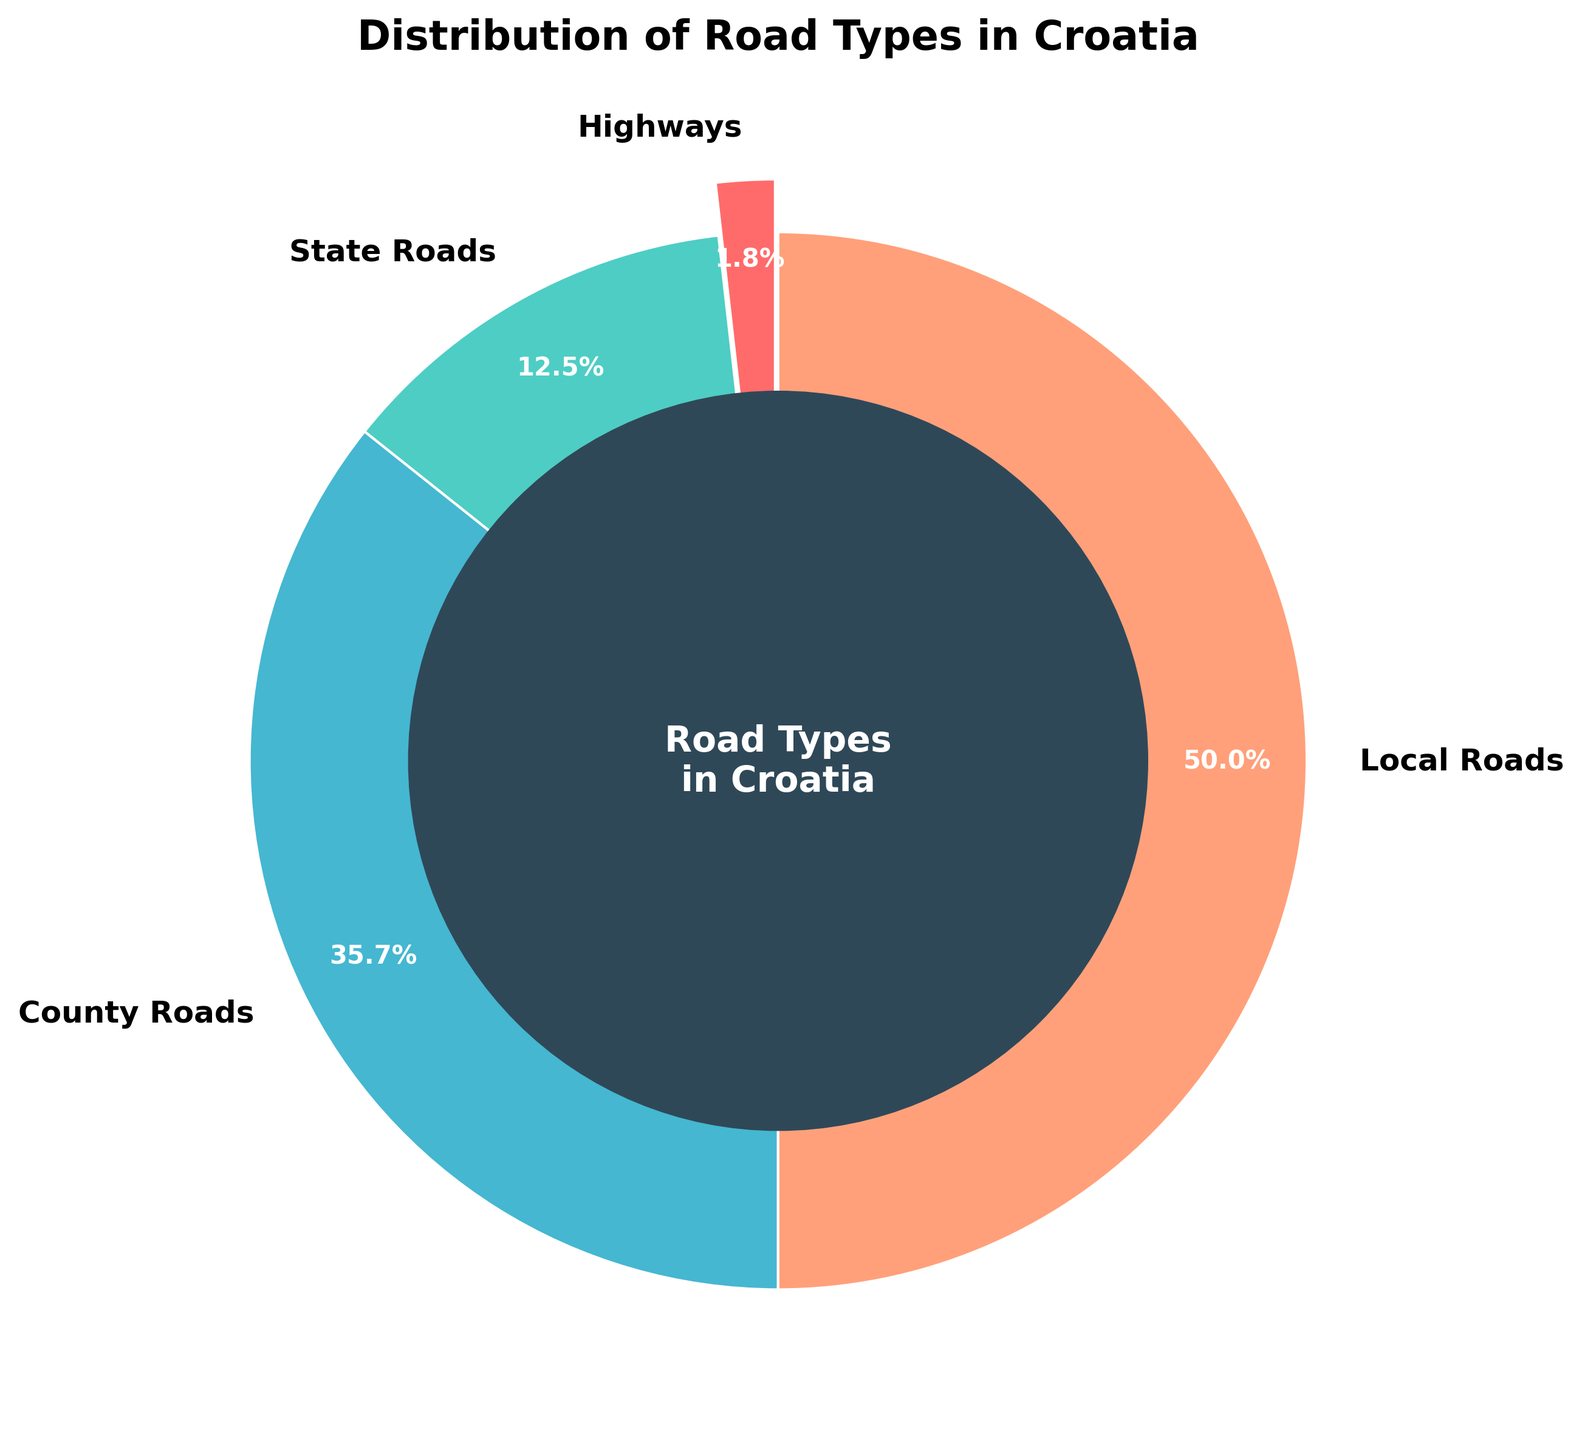Which road type has the highest percentage in the distribution? The road type with the highest percentage can be identified by finding the largest segment in the pie chart. Local Roads occupy the largest segment with 50%.
Answer: Local Roads Which road type has the smallest percentage? The road type with the smallest percentage is represented by the smallest segment in the pie chart. Highways occupy the smallest segment with 1.8%.
Answer: Highways What is the combined percentage of state roads and county roads? To find the combined percentage, sum the percentages of state roads and county roads: 12.5% + 35.7% = 48.2%.
Answer: 48.2% Which road type is closest to having half the total distribution? The road type closest to 50% can be identified by comparing the segments in the pie chart. Local Roads cover 50%, which is exactly half of the total distribution.
Answer: Local Roads If you combine the percentages of highways and state roads, would it be greater or smaller than the percentage of county roads? Combine the percentages of highways (1.8%) and state roads (12.5%), resulting in 1.8% + 12.5% = 14.3%. Compare this with the percentage of county roads (35.7%). 14.3% is less than 35.7%.
Answer: Smaller How many road types have a percentage greater than state roads? Observe the percentages of each road type in the pie chart. Both County Roads (35.7%) and Local Roads (50.0%) have percentages greater than State Roads (12.5%). Thus, there are two road types with a greater percentage.
Answer: Two Which color represents county roads in the pie chart? The color representing each road type can be identified from the color-coded labels. County Roads are represented by the color blue.
Answer: Blue Is the percentage of local roads greater than the total percentage of highways and state roads combined? Combine the percentages of highways (1.8%) and state roads (12.5%): 1.8% + 12.5% = 14.3%. Compare this with the percentage of local roads (50.0%). 50.0% is indeed greater than 14.3%.
Answer: Yes Which road type(s) are represented with a red wedge in the pie chart? The color red in the pie chart represents Highways, as indicated by the color-coded labels.
Answer: Highways How much more is the percentage of county roads compared to highways? Subtract the percentage of highways from the percentage of county roads: 35.7% - 1.8% = 33.9%.
Answer: 33.9% 